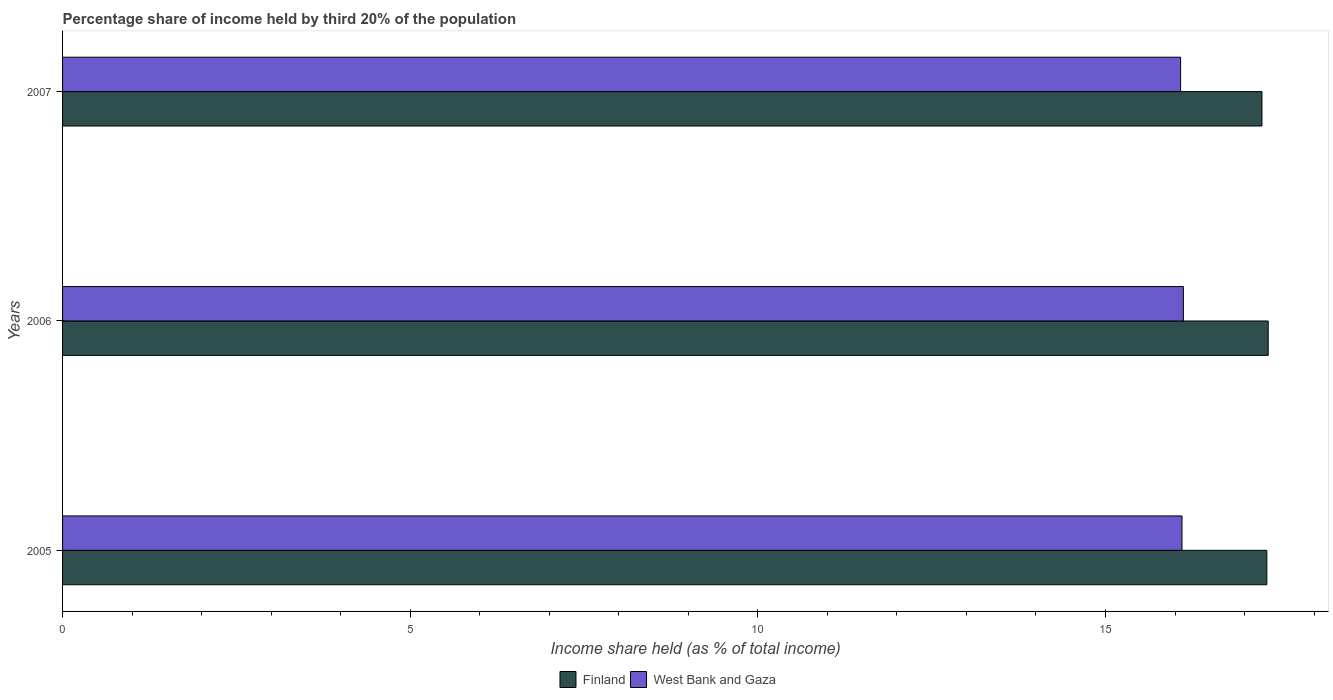Are the number of bars per tick equal to the number of legend labels?
Offer a terse response. Yes. Are the number of bars on each tick of the Y-axis equal?
Your answer should be very brief. Yes. How many bars are there on the 2nd tick from the bottom?
Ensure brevity in your answer.  2. What is the label of the 3rd group of bars from the top?
Provide a succinct answer. 2005. In how many cases, is the number of bars for a given year not equal to the number of legend labels?
Your response must be concise. 0. What is the share of income held by third 20% of the population in West Bank and Gaza in 2006?
Keep it short and to the point. 16.12. Across all years, what is the maximum share of income held by third 20% of the population in West Bank and Gaza?
Provide a short and direct response. 16.12. Across all years, what is the minimum share of income held by third 20% of the population in Finland?
Your response must be concise. 17.25. What is the total share of income held by third 20% of the population in Finland in the graph?
Offer a terse response. 51.91. What is the difference between the share of income held by third 20% of the population in Finland in 2005 and that in 2007?
Your answer should be compact. 0.07. What is the difference between the share of income held by third 20% of the population in Finland in 2005 and the share of income held by third 20% of the population in West Bank and Gaza in 2007?
Your response must be concise. 1.24. What is the average share of income held by third 20% of the population in West Bank and Gaza per year?
Ensure brevity in your answer.  16.1. In the year 2007, what is the difference between the share of income held by third 20% of the population in Finland and share of income held by third 20% of the population in West Bank and Gaza?
Give a very brief answer. 1.17. What is the ratio of the share of income held by third 20% of the population in Finland in 2005 to that in 2006?
Make the answer very short. 1. Is the difference between the share of income held by third 20% of the population in Finland in 2006 and 2007 greater than the difference between the share of income held by third 20% of the population in West Bank and Gaza in 2006 and 2007?
Provide a succinct answer. Yes. What is the difference between the highest and the second highest share of income held by third 20% of the population in Finland?
Your answer should be very brief. 0.02. What is the difference between the highest and the lowest share of income held by third 20% of the population in Finland?
Offer a very short reply. 0.09. In how many years, is the share of income held by third 20% of the population in West Bank and Gaza greater than the average share of income held by third 20% of the population in West Bank and Gaza taken over all years?
Your answer should be compact. 2. Is the sum of the share of income held by third 20% of the population in Finland in 2005 and 2006 greater than the maximum share of income held by third 20% of the population in West Bank and Gaza across all years?
Offer a terse response. Yes. What does the 1st bar from the top in 2007 represents?
Provide a succinct answer. West Bank and Gaza. What does the 2nd bar from the bottom in 2005 represents?
Provide a succinct answer. West Bank and Gaza. How many years are there in the graph?
Your answer should be very brief. 3. What is the difference between two consecutive major ticks on the X-axis?
Your answer should be compact. 5. Does the graph contain grids?
Offer a very short reply. No. How are the legend labels stacked?
Offer a very short reply. Horizontal. What is the title of the graph?
Offer a terse response. Percentage share of income held by third 20% of the population. What is the label or title of the X-axis?
Offer a very short reply. Income share held (as % of total income). What is the label or title of the Y-axis?
Give a very brief answer. Years. What is the Income share held (as % of total income) in Finland in 2005?
Your answer should be compact. 17.32. What is the Income share held (as % of total income) in West Bank and Gaza in 2005?
Keep it short and to the point. 16.1. What is the Income share held (as % of total income) in Finland in 2006?
Offer a very short reply. 17.34. What is the Income share held (as % of total income) in West Bank and Gaza in 2006?
Keep it short and to the point. 16.12. What is the Income share held (as % of total income) in Finland in 2007?
Provide a short and direct response. 17.25. What is the Income share held (as % of total income) of West Bank and Gaza in 2007?
Ensure brevity in your answer.  16.08. Across all years, what is the maximum Income share held (as % of total income) in Finland?
Make the answer very short. 17.34. Across all years, what is the maximum Income share held (as % of total income) in West Bank and Gaza?
Provide a short and direct response. 16.12. Across all years, what is the minimum Income share held (as % of total income) in Finland?
Your answer should be compact. 17.25. Across all years, what is the minimum Income share held (as % of total income) in West Bank and Gaza?
Give a very brief answer. 16.08. What is the total Income share held (as % of total income) of Finland in the graph?
Keep it short and to the point. 51.91. What is the total Income share held (as % of total income) of West Bank and Gaza in the graph?
Offer a terse response. 48.3. What is the difference between the Income share held (as % of total income) of Finland in 2005 and that in 2006?
Provide a short and direct response. -0.02. What is the difference between the Income share held (as % of total income) of West Bank and Gaza in 2005 and that in 2006?
Ensure brevity in your answer.  -0.02. What is the difference between the Income share held (as % of total income) of Finland in 2005 and that in 2007?
Make the answer very short. 0.07. What is the difference between the Income share held (as % of total income) of Finland in 2006 and that in 2007?
Your response must be concise. 0.09. What is the difference between the Income share held (as % of total income) of Finland in 2005 and the Income share held (as % of total income) of West Bank and Gaza in 2007?
Your response must be concise. 1.24. What is the difference between the Income share held (as % of total income) of Finland in 2006 and the Income share held (as % of total income) of West Bank and Gaza in 2007?
Provide a short and direct response. 1.26. What is the average Income share held (as % of total income) of Finland per year?
Make the answer very short. 17.3. In the year 2005, what is the difference between the Income share held (as % of total income) in Finland and Income share held (as % of total income) in West Bank and Gaza?
Offer a terse response. 1.22. In the year 2006, what is the difference between the Income share held (as % of total income) in Finland and Income share held (as % of total income) in West Bank and Gaza?
Make the answer very short. 1.22. In the year 2007, what is the difference between the Income share held (as % of total income) in Finland and Income share held (as % of total income) in West Bank and Gaza?
Your answer should be compact. 1.17. What is the ratio of the Income share held (as % of total income) in Finland in 2005 to that in 2006?
Your response must be concise. 1. What is the ratio of the Income share held (as % of total income) in West Bank and Gaza in 2005 to that in 2006?
Give a very brief answer. 1. What is the ratio of the Income share held (as % of total income) of West Bank and Gaza in 2005 to that in 2007?
Your answer should be compact. 1. What is the ratio of the Income share held (as % of total income) in West Bank and Gaza in 2006 to that in 2007?
Ensure brevity in your answer.  1. What is the difference between the highest and the second highest Income share held (as % of total income) in West Bank and Gaza?
Offer a terse response. 0.02. What is the difference between the highest and the lowest Income share held (as % of total income) of Finland?
Your response must be concise. 0.09. 